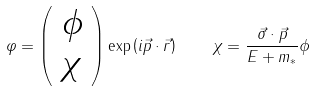Convert formula to latex. <formula><loc_0><loc_0><loc_500><loc_500>\varphi = \left ( \begin{array} { c } \phi \\ \chi \end{array} \right ) \exp \left ( i \vec { p } \cdot \vec { r } \right ) \quad \chi = \frac { \vec { \sigma } \cdot \vec { p } } { E + m _ { * } } \phi</formula> 